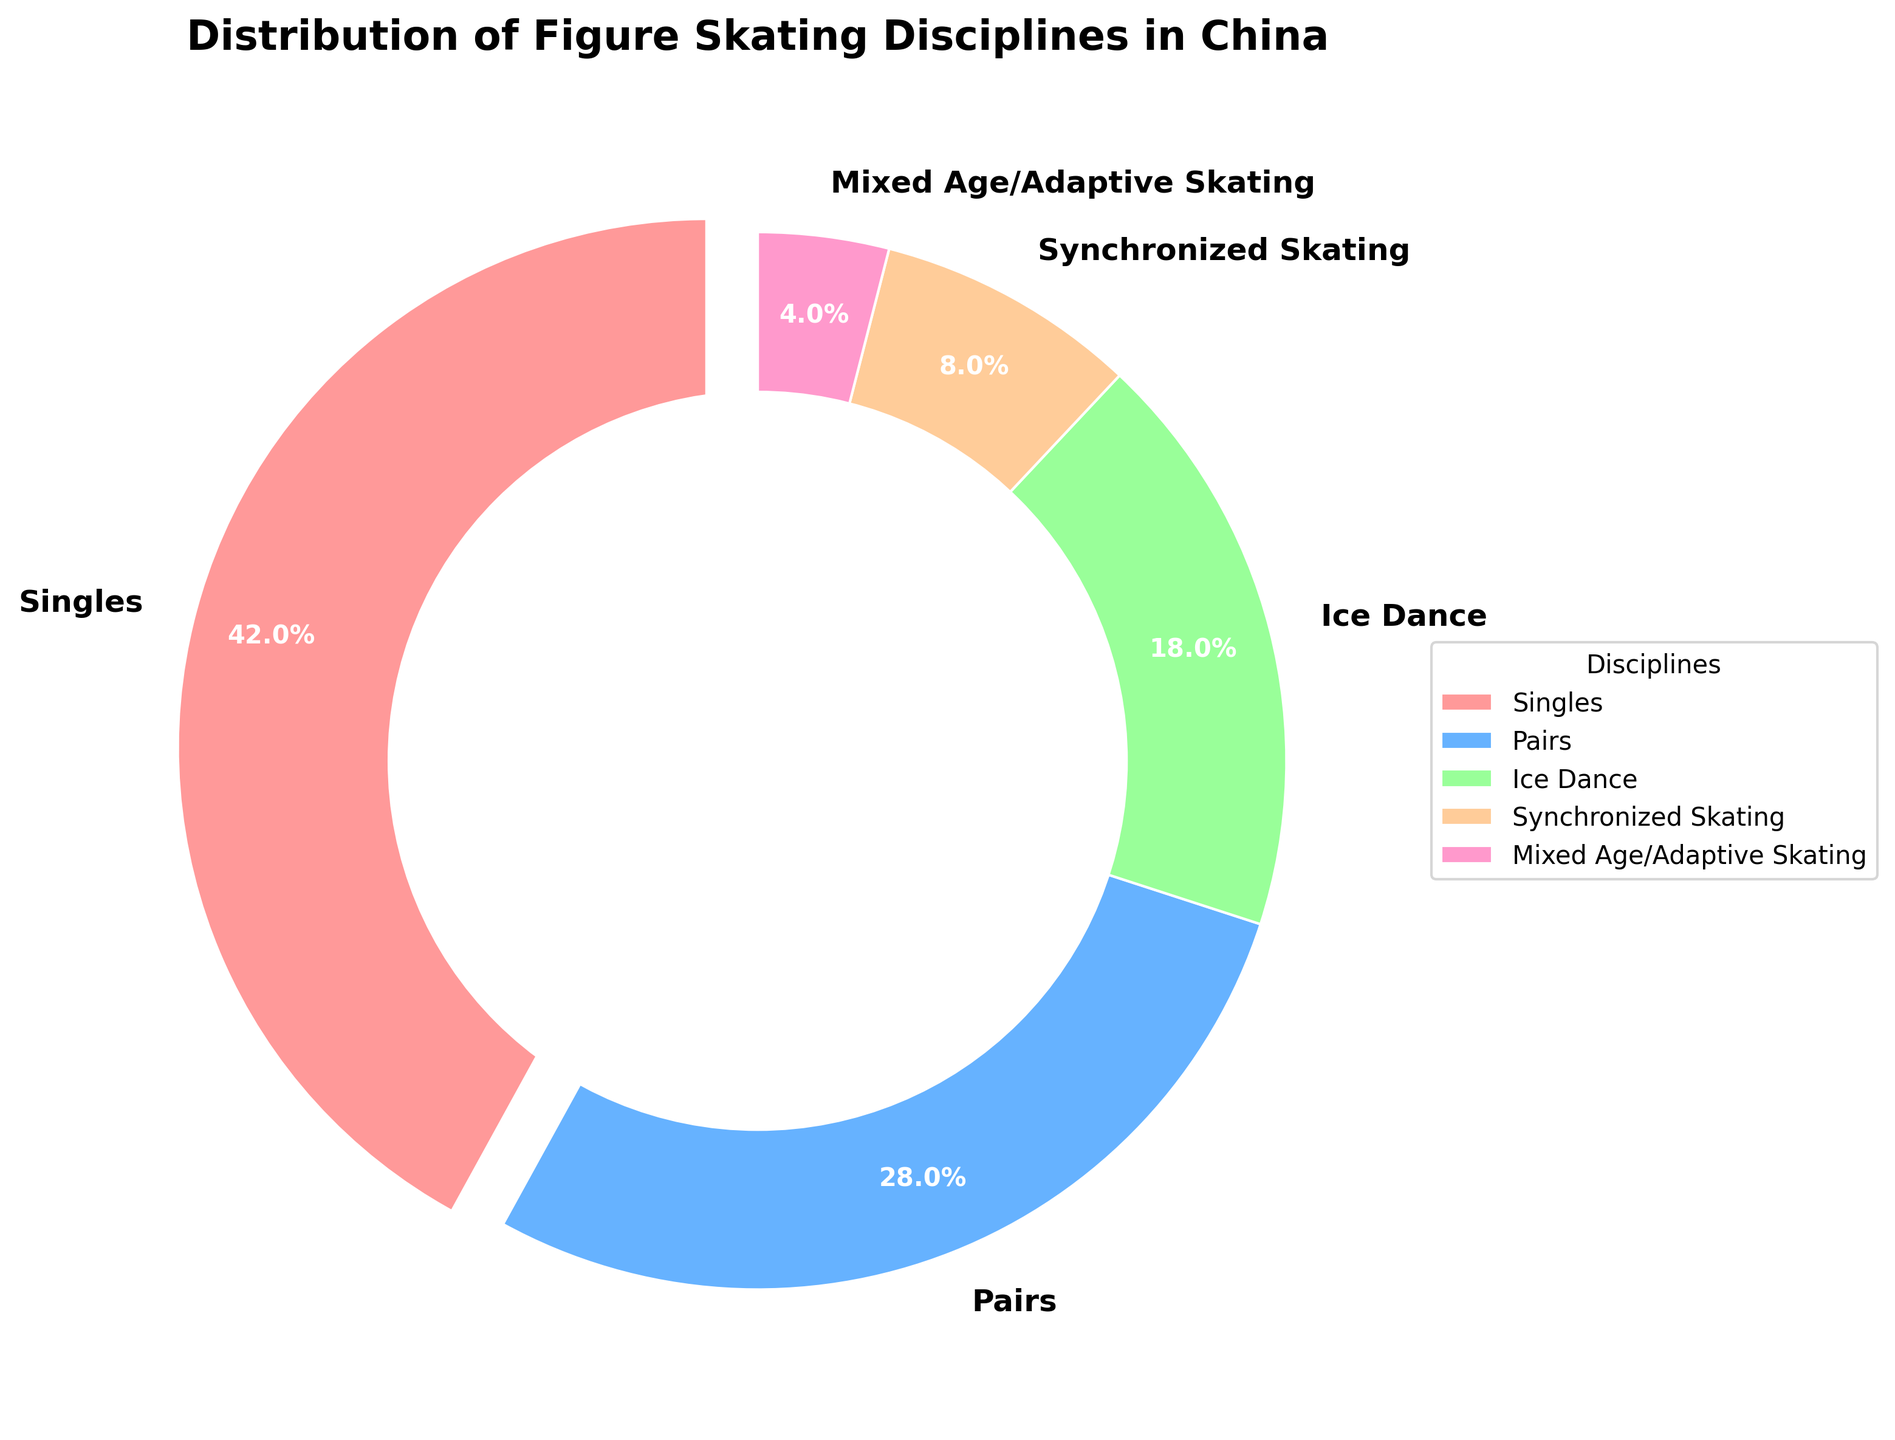What discipline constitutes less than 10% of the distribution? Look at the pie chart segments. Only "Synchronized Skating" and "Mixed Age/Adaptive Skating" have values less than 10%. Among them, "Mixed Age/Adaptive Skating" is the smallest and less than 10%.
Answer: Mixed Age/Adaptive Skating What percentage of skaters participate in Ice Dance and Pairs combined? Find the percentages for Ice Dance (18%) and Pairs (28%) in the pie chart. Sum them: 18% + 28% = 46%
Answer: 46% Is the percentage of Single skaters higher than the combined percentage of Synchronized Skating and Mixed Age/Adaptive Skating? Single skaters have 42%. Synchronized Skating (8%) + Mixed Age/Adaptive Skating (4%) = 12%. Since 42% is greater than 12%, the statement is true.
Answer: Yes Which discipline has the largest percentage of participants? Identify the segment with the largest percentage. "Singles" has the highest with 42%.
Answer: Singles How much larger is the percentage of Pairs compared to the percentage of Synchronized Skating? Pairs have 28%, and Synchronized Skating has 8%. Subtract the smaller percentage from the larger one: 28% - 8% = 20%
Answer: 20% Which disciplines together make up over half of the distribution? Examine the sum of percentages for each combination. Singles (42%) and Pairs (28%) sum to 70%, which is over half. Hence, these two disciplines together exceed 50%.
Answer: Singles and Pairs Is the percentage of Singles more than double that of Ice Dance? The percentage of Singles is 42%. If we double Ice Dance's 18%, we get 36%. Since 42% is more than 36%, the statement is true.
Answer: Yes What color represents the discipline with the second-largest percentage of participants? Identify the discipline and corresponding color from the legend. Pairs, the second largest, is represented by the blue color.
Answer: Blue 